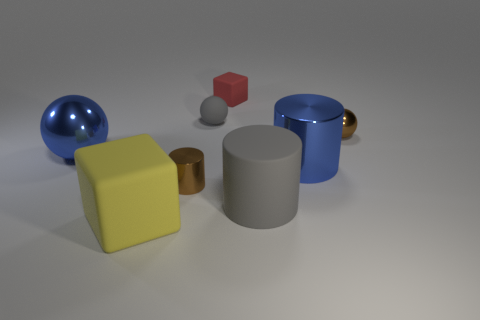There is a shiny ball on the left side of the big block; does it have the same color as the matte block on the right side of the big yellow matte block?
Provide a succinct answer. No. Are there any cubes in front of the brown metal cylinder?
Keep it short and to the point. Yes. What material is the small thing that is both to the right of the small gray matte thing and in front of the red cube?
Keep it short and to the point. Metal. Does the blue object that is on the left side of the big yellow rubber object have the same material as the gray cylinder?
Offer a very short reply. No. What is the material of the yellow cube?
Your answer should be compact. Rubber. What is the size of the brown metallic thing to the left of the small brown ball?
Provide a succinct answer. Small. Is there any other thing that is the same color as the small rubber cube?
Make the answer very short. No. There is a small thing that is in front of the tiny brown thing on the right side of the small red object; is there a gray thing that is on the left side of it?
Provide a succinct answer. No. There is a large cylinder behind the big gray matte thing; does it have the same color as the tiny metallic cylinder?
Your answer should be compact. No. How many balls are either gray matte objects or big rubber objects?
Keep it short and to the point. 1. 